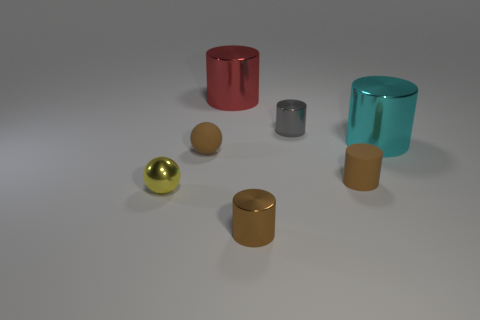What number of tiny objects are both in front of the small rubber cylinder and to the right of the tiny yellow metallic sphere?
Offer a terse response. 1. How many other objects are there of the same size as the brown shiny cylinder?
Your response must be concise. 4. There is a big thing that is to the left of the big cyan metallic thing; is it the same shape as the metallic object to the left of the red metallic thing?
Your response must be concise. No. How many things are either small cylinders or tiny metal cylinders behind the large cyan cylinder?
Ensure brevity in your answer.  3. There is a cylinder that is left of the gray metal cylinder and in front of the cyan cylinder; what is its material?
Offer a terse response. Metal. Are there any other things that have the same shape as the tiny brown shiny object?
Offer a terse response. Yes. What is the color of the tiny ball that is made of the same material as the cyan object?
Make the answer very short. Yellow. What number of objects are either small brown spheres or brown things?
Your response must be concise. 3. Is the size of the gray thing the same as the cylinder that is in front of the small yellow shiny thing?
Offer a terse response. Yes. What color is the large cylinder that is left of the big object right of the brown rubber thing right of the small brown shiny object?
Provide a short and direct response. Red. 